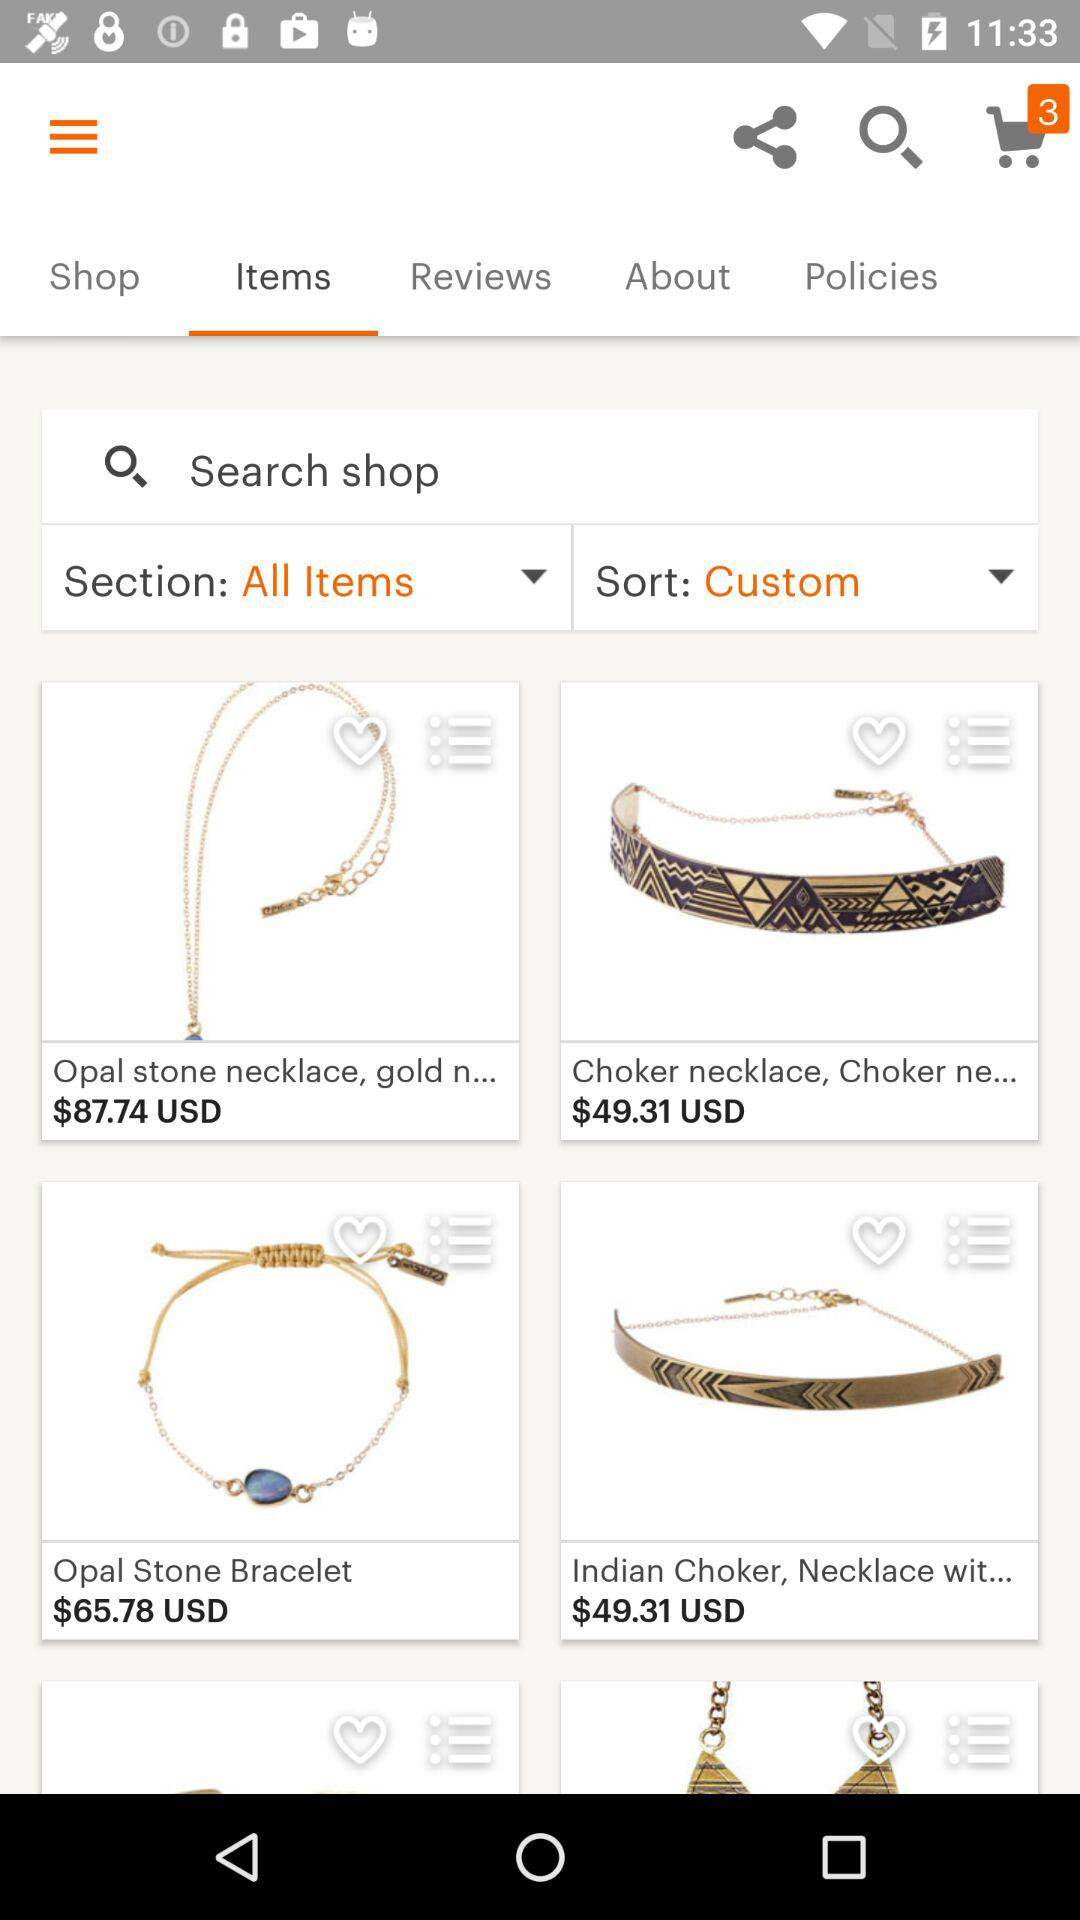Which necklace costs $49.31 in US dollars? The necklaces, which cost $49.31 are "Choker necklace, Choker ne..." and "Indian Choker, Necklace wit...". 